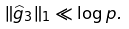Convert formula to latex. <formula><loc_0><loc_0><loc_500><loc_500>\| \widehat { g } _ { 3 } \| _ { 1 } \ll \log p .</formula> 